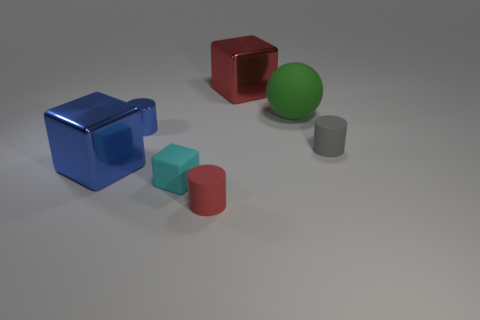Subtract all blue cubes. How many cubes are left? 2 Subtract all blocks. How many objects are left? 4 Add 3 big green matte balls. How many objects exist? 10 Subtract all gray cylinders. How many cylinders are left? 2 Subtract 1 cylinders. How many cylinders are left? 2 Subtract all gray balls. How many blue cylinders are left? 1 Subtract all yellow blocks. Subtract all green cylinders. How many blocks are left? 3 Subtract all big red rubber objects. Subtract all blue cylinders. How many objects are left? 6 Add 7 blocks. How many blocks are left? 10 Add 2 green spheres. How many green spheres exist? 3 